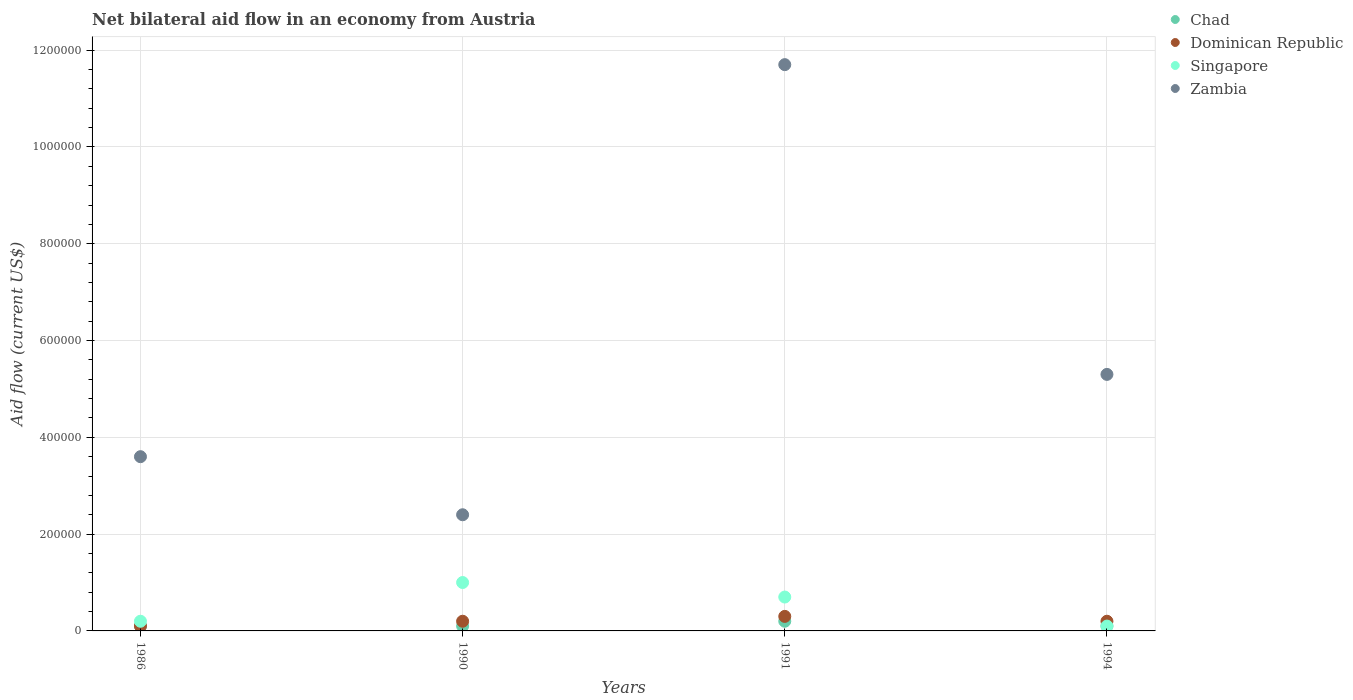How many different coloured dotlines are there?
Provide a succinct answer. 4. Is the number of dotlines equal to the number of legend labels?
Make the answer very short. Yes. What is the net bilateral aid flow in Singapore in 1986?
Ensure brevity in your answer.  2.00e+04. Across all years, what is the maximum net bilateral aid flow in Singapore?
Your answer should be compact. 1.00e+05. Across all years, what is the minimum net bilateral aid flow in Zambia?
Give a very brief answer. 2.40e+05. What is the difference between the net bilateral aid flow in Singapore in 1991 and that in 1994?
Offer a terse response. 6.00e+04. What is the difference between the net bilateral aid flow in Zambia in 1991 and the net bilateral aid flow in Singapore in 1986?
Keep it short and to the point. 1.15e+06. What is the average net bilateral aid flow in Singapore per year?
Ensure brevity in your answer.  5.00e+04. In the year 1991, what is the difference between the net bilateral aid flow in Zambia and net bilateral aid flow in Chad?
Offer a very short reply. 1.15e+06. In how many years, is the net bilateral aid flow in Chad greater than 520000 US$?
Offer a very short reply. 0. What is the ratio of the net bilateral aid flow in Singapore in 1990 to that in 1994?
Provide a short and direct response. 10. Is the net bilateral aid flow in Chad in 1990 less than that in 1994?
Your answer should be compact. No. What is the difference between the highest and the lowest net bilateral aid flow in Singapore?
Give a very brief answer. 9.00e+04. In how many years, is the net bilateral aid flow in Chad greater than the average net bilateral aid flow in Chad taken over all years?
Ensure brevity in your answer.  1. Is the sum of the net bilateral aid flow in Dominican Republic in 1986 and 1991 greater than the maximum net bilateral aid flow in Singapore across all years?
Your answer should be very brief. No. Does the net bilateral aid flow in Chad monotonically increase over the years?
Make the answer very short. No. How many dotlines are there?
Ensure brevity in your answer.  4. How many years are there in the graph?
Provide a short and direct response. 4. Are the values on the major ticks of Y-axis written in scientific E-notation?
Ensure brevity in your answer.  No. Does the graph contain any zero values?
Make the answer very short. No. How are the legend labels stacked?
Make the answer very short. Vertical. What is the title of the graph?
Offer a very short reply. Net bilateral aid flow in an economy from Austria. Does "Romania" appear as one of the legend labels in the graph?
Your answer should be very brief. No. What is the label or title of the Y-axis?
Your answer should be compact. Aid flow (current US$). What is the Aid flow (current US$) in Zambia in 1986?
Keep it short and to the point. 3.60e+05. What is the Aid flow (current US$) in Chad in 1990?
Your answer should be compact. 10000. What is the Aid flow (current US$) in Singapore in 1990?
Provide a short and direct response. 1.00e+05. What is the Aid flow (current US$) in Zambia in 1990?
Provide a short and direct response. 2.40e+05. What is the Aid flow (current US$) in Zambia in 1991?
Your response must be concise. 1.17e+06. What is the Aid flow (current US$) in Chad in 1994?
Provide a short and direct response. 10000. What is the Aid flow (current US$) of Dominican Republic in 1994?
Make the answer very short. 2.00e+04. What is the Aid flow (current US$) of Singapore in 1994?
Offer a terse response. 10000. What is the Aid flow (current US$) of Zambia in 1994?
Provide a succinct answer. 5.30e+05. Across all years, what is the maximum Aid flow (current US$) of Dominican Republic?
Offer a very short reply. 3.00e+04. Across all years, what is the maximum Aid flow (current US$) of Singapore?
Offer a terse response. 1.00e+05. Across all years, what is the maximum Aid flow (current US$) in Zambia?
Your answer should be very brief. 1.17e+06. Across all years, what is the minimum Aid flow (current US$) of Chad?
Keep it short and to the point. 10000. What is the total Aid flow (current US$) of Singapore in the graph?
Give a very brief answer. 2.00e+05. What is the total Aid flow (current US$) of Zambia in the graph?
Your answer should be compact. 2.30e+06. What is the difference between the Aid flow (current US$) in Dominican Republic in 1986 and that in 1990?
Make the answer very short. -10000. What is the difference between the Aid flow (current US$) of Singapore in 1986 and that in 1990?
Offer a terse response. -8.00e+04. What is the difference between the Aid flow (current US$) of Chad in 1986 and that in 1991?
Ensure brevity in your answer.  -10000. What is the difference between the Aid flow (current US$) in Dominican Republic in 1986 and that in 1991?
Keep it short and to the point. -2.00e+04. What is the difference between the Aid flow (current US$) in Singapore in 1986 and that in 1991?
Provide a short and direct response. -5.00e+04. What is the difference between the Aid flow (current US$) in Zambia in 1986 and that in 1991?
Ensure brevity in your answer.  -8.10e+05. What is the difference between the Aid flow (current US$) of Chad in 1986 and that in 1994?
Ensure brevity in your answer.  0. What is the difference between the Aid flow (current US$) in Singapore in 1986 and that in 1994?
Make the answer very short. 10000. What is the difference between the Aid flow (current US$) of Zambia in 1986 and that in 1994?
Keep it short and to the point. -1.70e+05. What is the difference between the Aid flow (current US$) of Zambia in 1990 and that in 1991?
Ensure brevity in your answer.  -9.30e+05. What is the difference between the Aid flow (current US$) in Chad in 1990 and that in 1994?
Keep it short and to the point. 0. What is the difference between the Aid flow (current US$) in Dominican Republic in 1990 and that in 1994?
Give a very brief answer. 0. What is the difference between the Aid flow (current US$) in Zambia in 1990 and that in 1994?
Provide a short and direct response. -2.90e+05. What is the difference between the Aid flow (current US$) of Chad in 1991 and that in 1994?
Ensure brevity in your answer.  10000. What is the difference between the Aid flow (current US$) in Zambia in 1991 and that in 1994?
Give a very brief answer. 6.40e+05. What is the difference between the Aid flow (current US$) of Chad in 1986 and the Aid flow (current US$) of Dominican Republic in 1990?
Provide a short and direct response. -10000. What is the difference between the Aid flow (current US$) in Chad in 1986 and the Aid flow (current US$) in Dominican Republic in 1991?
Provide a short and direct response. -2.00e+04. What is the difference between the Aid flow (current US$) in Chad in 1986 and the Aid flow (current US$) in Zambia in 1991?
Make the answer very short. -1.16e+06. What is the difference between the Aid flow (current US$) in Dominican Republic in 1986 and the Aid flow (current US$) in Singapore in 1991?
Your response must be concise. -6.00e+04. What is the difference between the Aid flow (current US$) in Dominican Republic in 1986 and the Aid flow (current US$) in Zambia in 1991?
Your answer should be compact. -1.16e+06. What is the difference between the Aid flow (current US$) in Singapore in 1986 and the Aid flow (current US$) in Zambia in 1991?
Provide a succinct answer. -1.15e+06. What is the difference between the Aid flow (current US$) in Chad in 1986 and the Aid flow (current US$) in Zambia in 1994?
Provide a short and direct response. -5.20e+05. What is the difference between the Aid flow (current US$) of Dominican Republic in 1986 and the Aid flow (current US$) of Singapore in 1994?
Keep it short and to the point. 0. What is the difference between the Aid flow (current US$) of Dominican Republic in 1986 and the Aid flow (current US$) of Zambia in 1994?
Offer a terse response. -5.20e+05. What is the difference between the Aid flow (current US$) in Singapore in 1986 and the Aid flow (current US$) in Zambia in 1994?
Give a very brief answer. -5.10e+05. What is the difference between the Aid flow (current US$) in Chad in 1990 and the Aid flow (current US$) in Dominican Republic in 1991?
Make the answer very short. -2.00e+04. What is the difference between the Aid flow (current US$) of Chad in 1990 and the Aid flow (current US$) of Singapore in 1991?
Make the answer very short. -6.00e+04. What is the difference between the Aid flow (current US$) in Chad in 1990 and the Aid flow (current US$) in Zambia in 1991?
Your response must be concise. -1.16e+06. What is the difference between the Aid flow (current US$) in Dominican Republic in 1990 and the Aid flow (current US$) in Singapore in 1991?
Offer a very short reply. -5.00e+04. What is the difference between the Aid flow (current US$) in Dominican Republic in 1990 and the Aid flow (current US$) in Zambia in 1991?
Keep it short and to the point. -1.15e+06. What is the difference between the Aid flow (current US$) in Singapore in 1990 and the Aid flow (current US$) in Zambia in 1991?
Offer a very short reply. -1.07e+06. What is the difference between the Aid flow (current US$) of Chad in 1990 and the Aid flow (current US$) of Dominican Republic in 1994?
Ensure brevity in your answer.  -10000. What is the difference between the Aid flow (current US$) of Chad in 1990 and the Aid flow (current US$) of Zambia in 1994?
Your answer should be compact. -5.20e+05. What is the difference between the Aid flow (current US$) in Dominican Republic in 1990 and the Aid flow (current US$) in Zambia in 1994?
Make the answer very short. -5.10e+05. What is the difference between the Aid flow (current US$) in Singapore in 1990 and the Aid flow (current US$) in Zambia in 1994?
Provide a short and direct response. -4.30e+05. What is the difference between the Aid flow (current US$) in Chad in 1991 and the Aid flow (current US$) in Singapore in 1994?
Keep it short and to the point. 10000. What is the difference between the Aid flow (current US$) in Chad in 1991 and the Aid flow (current US$) in Zambia in 1994?
Keep it short and to the point. -5.10e+05. What is the difference between the Aid flow (current US$) of Dominican Republic in 1991 and the Aid flow (current US$) of Singapore in 1994?
Your answer should be very brief. 2.00e+04. What is the difference between the Aid flow (current US$) of Dominican Republic in 1991 and the Aid flow (current US$) of Zambia in 1994?
Offer a very short reply. -5.00e+05. What is the difference between the Aid flow (current US$) of Singapore in 1991 and the Aid flow (current US$) of Zambia in 1994?
Ensure brevity in your answer.  -4.60e+05. What is the average Aid flow (current US$) in Chad per year?
Offer a terse response. 1.25e+04. What is the average Aid flow (current US$) of Dominican Republic per year?
Offer a very short reply. 2.00e+04. What is the average Aid flow (current US$) in Singapore per year?
Your answer should be compact. 5.00e+04. What is the average Aid flow (current US$) of Zambia per year?
Your answer should be very brief. 5.75e+05. In the year 1986, what is the difference between the Aid flow (current US$) in Chad and Aid flow (current US$) in Zambia?
Make the answer very short. -3.50e+05. In the year 1986, what is the difference between the Aid flow (current US$) of Dominican Republic and Aid flow (current US$) of Singapore?
Provide a short and direct response. -10000. In the year 1986, what is the difference between the Aid flow (current US$) in Dominican Republic and Aid flow (current US$) in Zambia?
Offer a terse response. -3.50e+05. In the year 1990, what is the difference between the Aid flow (current US$) in Chad and Aid flow (current US$) in Singapore?
Make the answer very short. -9.00e+04. In the year 1990, what is the difference between the Aid flow (current US$) of Singapore and Aid flow (current US$) of Zambia?
Ensure brevity in your answer.  -1.40e+05. In the year 1991, what is the difference between the Aid flow (current US$) of Chad and Aid flow (current US$) of Dominican Republic?
Give a very brief answer. -10000. In the year 1991, what is the difference between the Aid flow (current US$) of Chad and Aid flow (current US$) of Zambia?
Your answer should be compact. -1.15e+06. In the year 1991, what is the difference between the Aid flow (current US$) of Dominican Republic and Aid flow (current US$) of Zambia?
Ensure brevity in your answer.  -1.14e+06. In the year 1991, what is the difference between the Aid flow (current US$) of Singapore and Aid flow (current US$) of Zambia?
Keep it short and to the point. -1.10e+06. In the year 1994, what is the difference between the Aid flow (current US$) of Chad and Aid flow (current US$) of Dominican Republic?
Make the answer very short. -10000. In the year 1994, what is the difference between the Aid flow (current US$) of Chad and Aid flow (current US$) of Zambia?
Your response must be concise. -5.20e+05. In the year 1994, what is the difference between the Aid flow (current US$) of Dominican Republic and Aid flow (current US$) of Singapore?
Keep it short and to the point. 10000. In the year 1994, what is the difference between the Aid flow (current US$) of Dominican Republic and Aid flow (current US$) of Zambia?
Provide a short and direct response. -5.10e+05. In the year 1994, what is the difference between the Aid flow (current US$) in Singapore and Aid flow (current US$) in Zambia?
Provide a succinct answer. -5.20e+05. What is the ratio of the Aid flow (current US$) of Chad in 1986 to that in 1991?
Make the answer very short. 0.5. What is the ratio of the Aid flow (current US$) of Dominican Republic in 1986 to that in 1991?
Offer a very short reply. 0.33. What is the ratio of the Aid flow (current US$) in Singapore in 1986 to that in 1991?
Your answer should be compact. 0.29. What is the ratio of the Aid flow (current US$) in Zambia in 1986 to that in 1991?
Provide a short and direct response. 0.31. What is the ratio of the Aid flow (current US$) of Singapore in 1986 to that in 1994?
Provide a succinct answer. 2. What is the ratio of the Aid flow (current US$) in Zambia in 1986 to that in 1994?
Your response must be concise. 0.68. What is the ratio of the Aid flow (current US$) in Chad in 1990 to that in 1991?
Your response must be concise. 0.5. What is the ratio of the Aid flow (current US$) in Dominican Republic in 1990 to that in 1991?
Ensure brevity in your answer.  0.67. What is the ratio of the Aid flow (current US$) of Singapore in 1990 to that in 1991?
Ensure brevity in your answer.  1.43. What is the ratio of the Aid flow (current US$) of Zambia in 1990 to that in 1991?
Keep it short and to the point. 0.21. What is the ratio of the Aid flow (current US$) in Dominican Republic in 1990 to that in 1994?
Offer a very short reply. 1. What is the ratio of the Aid flow (current US$) of Zambia in 1990 to that in 1994?
Your answer should be very brief. 0.45. What is the ratio of the Aid flow (current US$) in Chad in 1991 to that in 1994?
Your answer should be very brief. 2. What is the ratio of the Aid flow (current US$) in Dominican Republic in 1991 to that in 1994?
Your response must be concise. 1.5. What is the ratio of the Aid flow (current US$) of Singapore in 1991 to that in 1994?
Keep it short and to the point. 7. What is the ratio of the Aid flow (current US$) of Zambia in 1991 to that in 1994?
Keep it short and to the point. 2.21. What is the difference between the highest and the second highest Aid flow (current US$) in Chad?
Offer a very short reply. 10000. What is the difference between the highest and the second highest Aid flow (current US$) in Dominican Republic?
Offer a very short reply. 10000. What is the difference between the highest and the second highest Aid flow (current US$) of Singapore?
Your answer should be compact. 3.00e+04. What is the difference between the highest and the second highest Aid flow (current US$) of Zambia?
Keep it short and to the point. 6.40e+05. What is the difference between the highest and the lowest Aid flow (current US$) of Singapore?
Your response must be concise. 9.00e+04. What is the difference between the highest and the lowest Aid flow (current US$) of Zambia?
Offer a very short reply. 9.30e+05. 